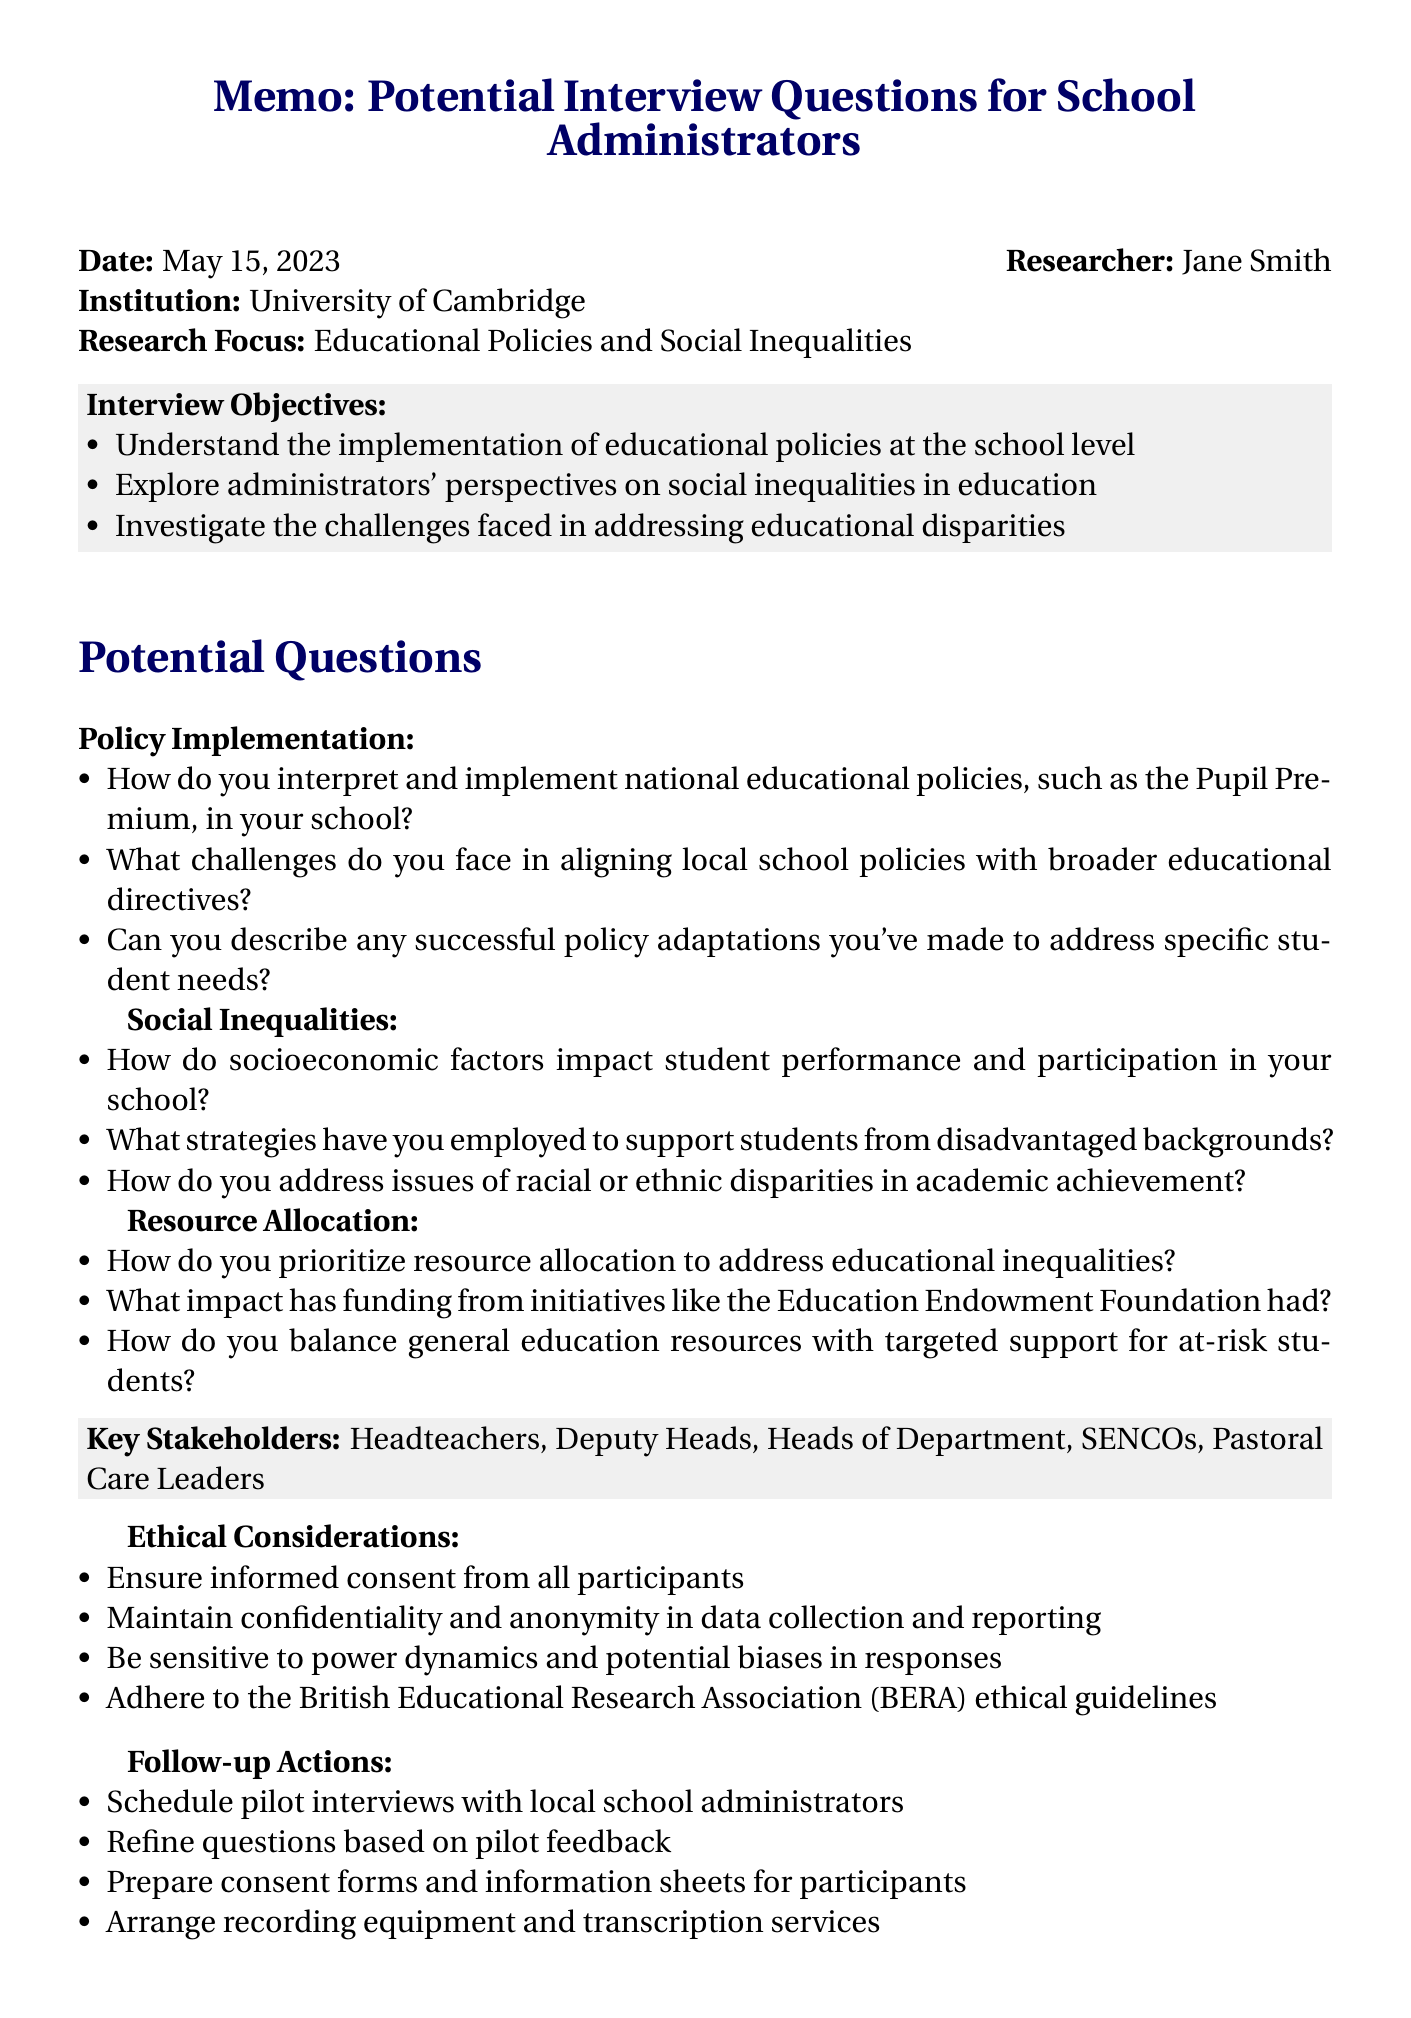What is the title of the memo? The title of the memo is found at the beginning of the document, which summarizes the purpose of the content.
Answer: Potential Interview Questions for School Administrators - Fieldwork Preparation Who is the researcher? The researcher is mentioned in the header section of the memo along with their name, providing clear authorship of the document.
Answer: Jane Smith What is the date of the memo? The date of the memo is crucial as it indicates when the document was created or last updated.
Answer: May 15, 2023 What is one of the interview objectives? An interview objective is listed in a bullet format to guide the purpose of the interviews.
Answer: Understand the implementation of educational policies at the school level What category does the question about 'socioeconomic factors' fall under? Each question in the memo is categorized, helping to organize the topics to be discussed during the interviews.
Answer: Social Inequalities Who are considered key stakeholders in the memo? The memo lists key stakeholders relevant to the research, indicating the level of involvement required in the interviews.
Answer: Headteachers, Deputy Heads, Heads of Department, SENCOs, Pastoral Care Leaders What is one ethical consideration mentioned? Ethical considerations reflect the importance of maintaining integrity and respect during the research process, as outlined in a specific section.
Answer: Ensure informed consent from all participants What type of questions are included in the potential questions section? The section categorizes questions based on themes relevant to the interview objectives, which helps in structuring the interviews.
Answer: Policy Implementation, Social Inequalities, Resource Allocation, Collaboration and Community Engagement, Measuring Impact What is the purpose of the follow-up actions listed? Follow-up actions detail the next steps necessary after the memo, ensuring further progress in the research project.
Answer: Schedule pilot interviews with local school administrators 